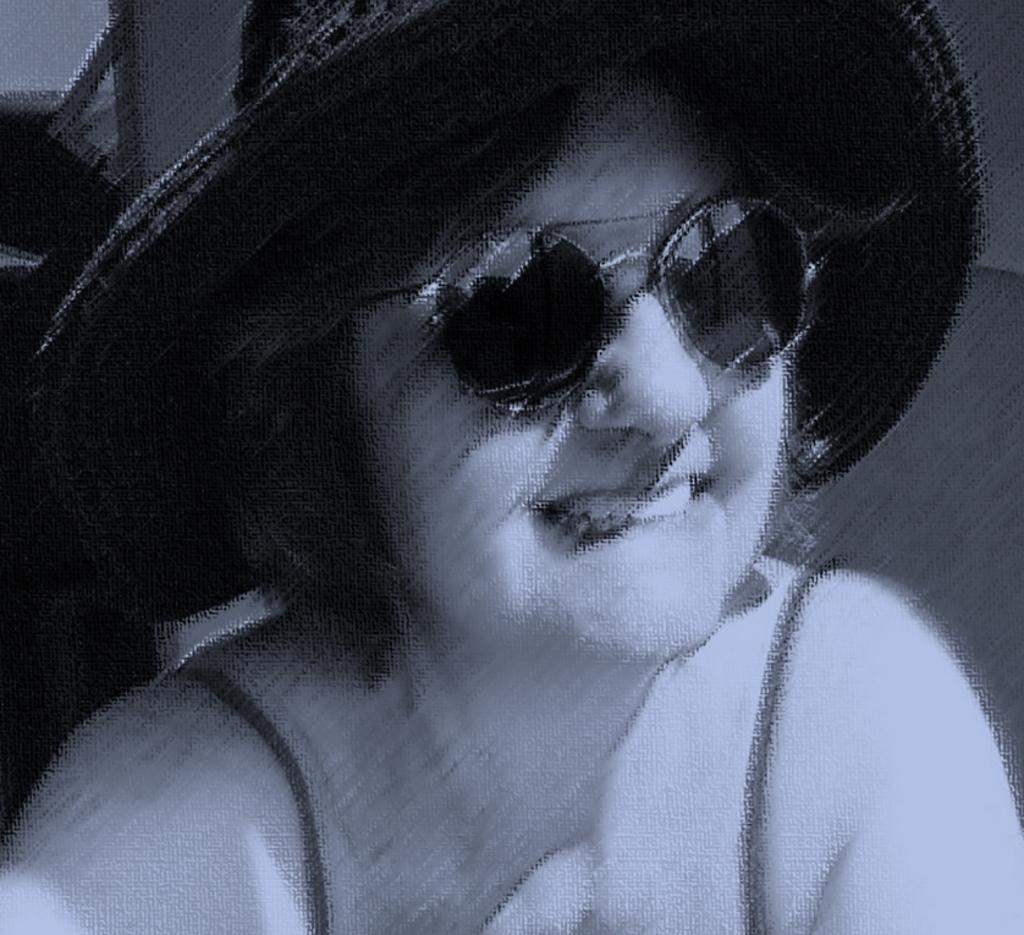Who or what is the main subject of the image? There is a person in the image. What protective gear is the person wearing? The person is wearing goggles and a hat. What is the color scheme of the image? The image is in black and white. What is the name of the nation that the person is representing in the image? There is no indication of a nation or representation in the image. 